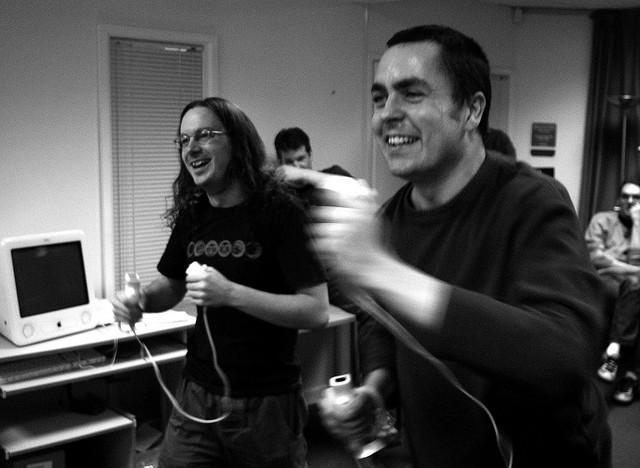How many people are in the picture?
Give a very brief answer. 4. How many tvs can you see?
Give a very brief answer. 1. 